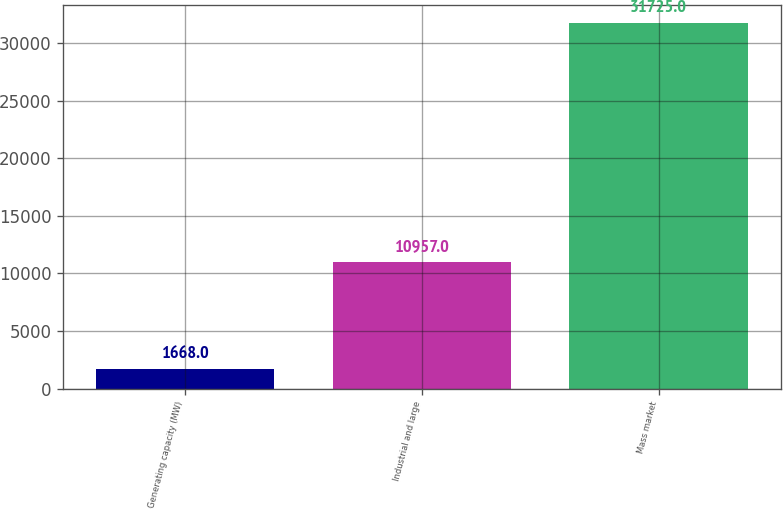Convert chart. <chart><loc_0><loc_0><loc_500><loc_500><bar_chart><fcel>Generating capacity (MW)<fcel>Industrial and large<fcel>Mass market<nl><fcel>1668<fcel>10957<fcel>31725<nl></chart> 